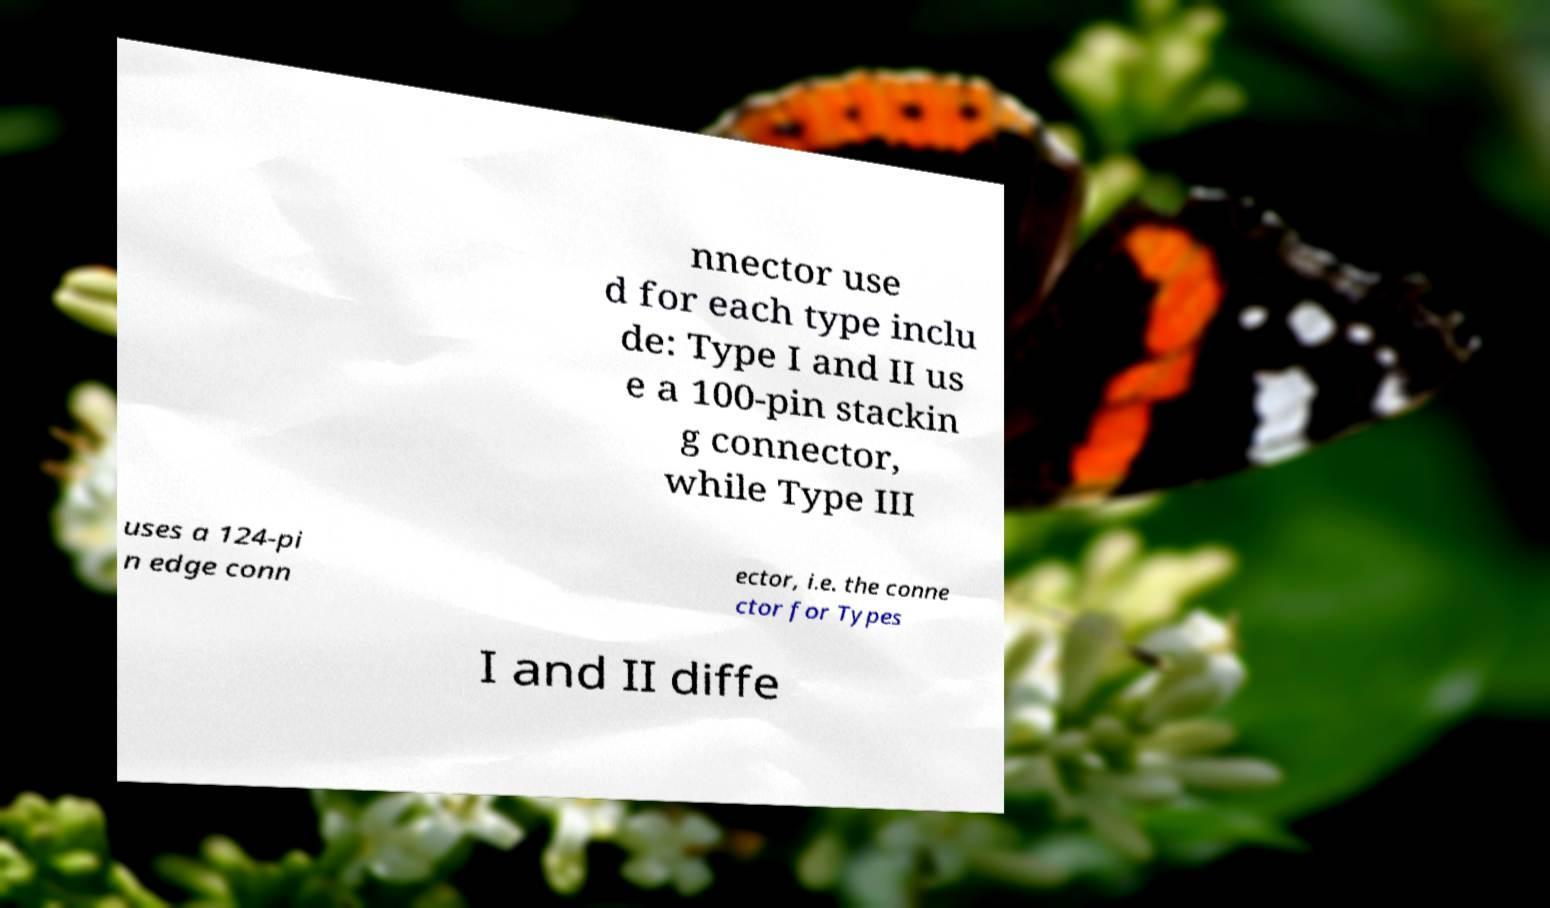Please identify and transcribe the text found in this image. nnector use d for each type inclu de: Type I and II us e a 100-pin stackin g connector, while Type III uses a 124-pi n edge conn ector, i.e. the conne ctor for Types I and II diffe 